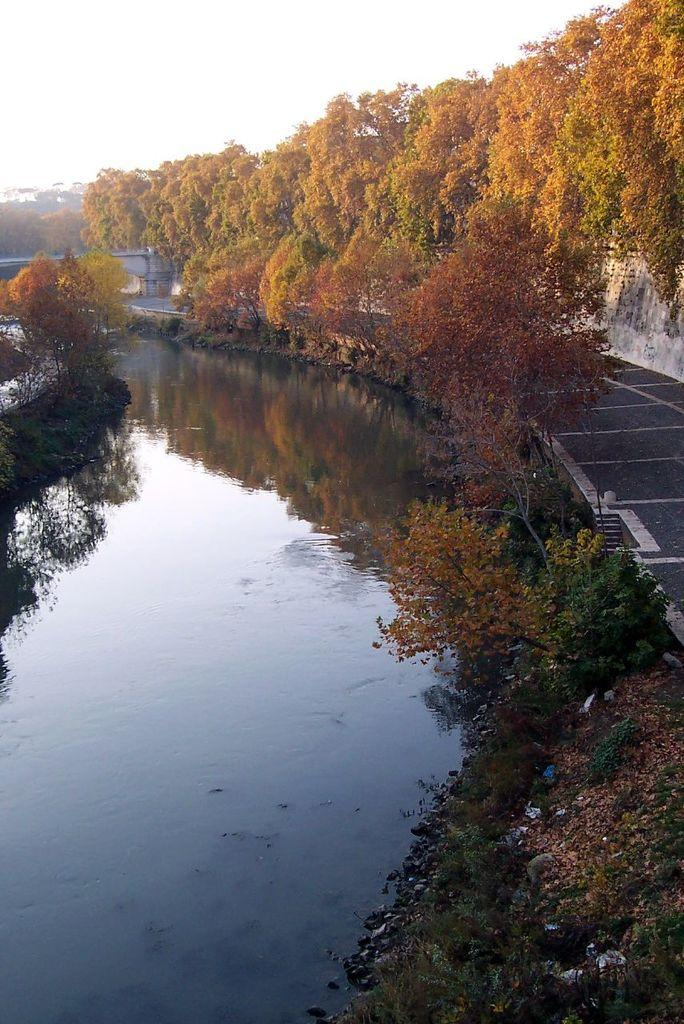What type of vegetation is on the right side of the image? There are trees on the right side of the image. What can be seen in the center of the image? There is water in the center of the image. How would you describe the sky in the image? The sky is cloudy. What type of plastic object can be seen floating in the water in the image? There is no plastic object visible in the water in the image. What type of grass is growing on the trees in the image? The trees in the image do not have grass growing on them; they are trees with leaves. 